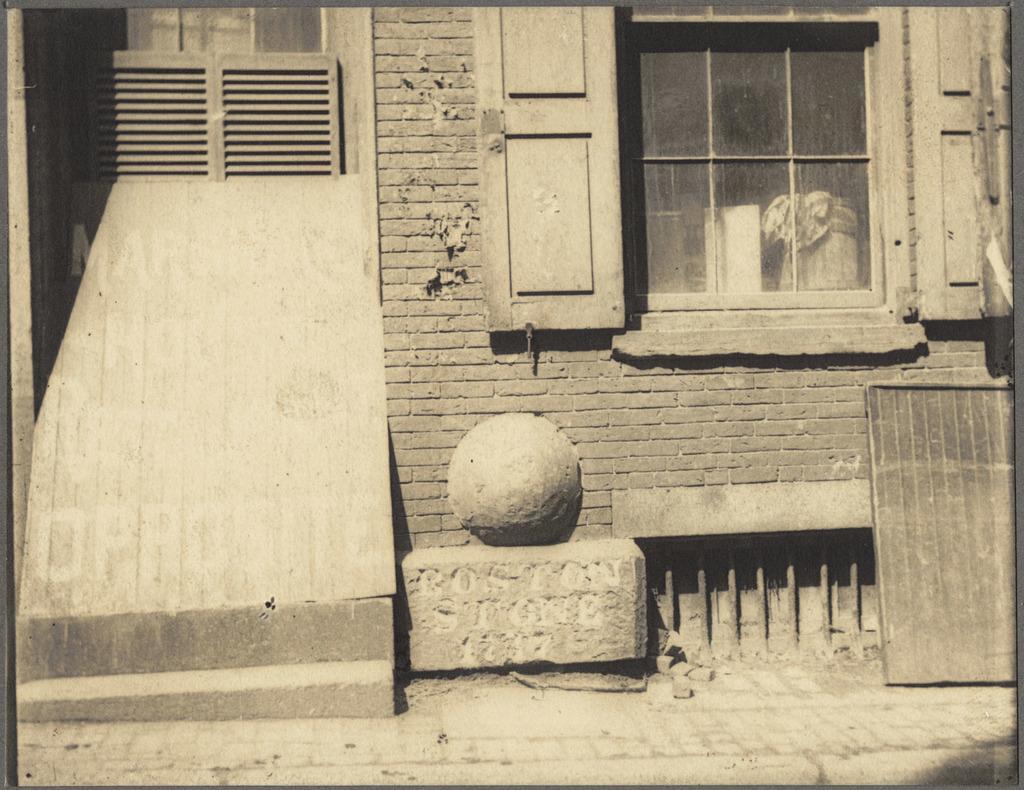How would you summarize this image in a sentence or two? Here in this picture we can see a house present, on which we can see windows with doors on it over there and on the right side we can see a wooden plank present on the ground over there. 